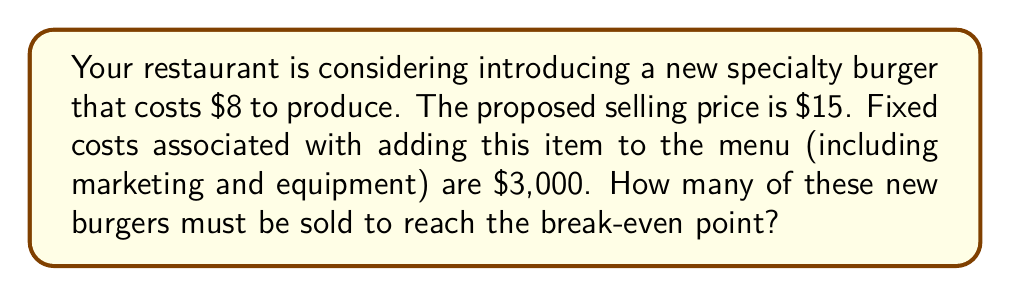Give your solution to this math problem. Let's approach this step-by-step:

1) First, we need to identify the key components:
   - Selling price per unit (P) = $15
   - Variable cost per unit (V) = $8
   - Fixed costs (F) = $3,000

2) The contribution margin (CM) per unit is the selling price minus the variable cost:
   $$ CM = P - V = $15 - $8 = $7 $$

3) The break-even point (BEP) in units is calculated by dividing the fixed costs by the contribution margin per unit:

   $$ BEP_{units} = \frac{F}{CM} $$

4) Substituting our values:

   $$ BEP_{units} = \frac{$3,000}{$7} $$

5) Performing the division:

   $$ BEP_{units} = 428.57 $$

6) Since we can't sell a fraction of a burger, we round up to the nearest whole number:

   $$ BEP_{units} = 429 $$

Therefore, the restaurant needs to sell 429 of these new specialty burgers to break even.
Answer: 429 burgers 